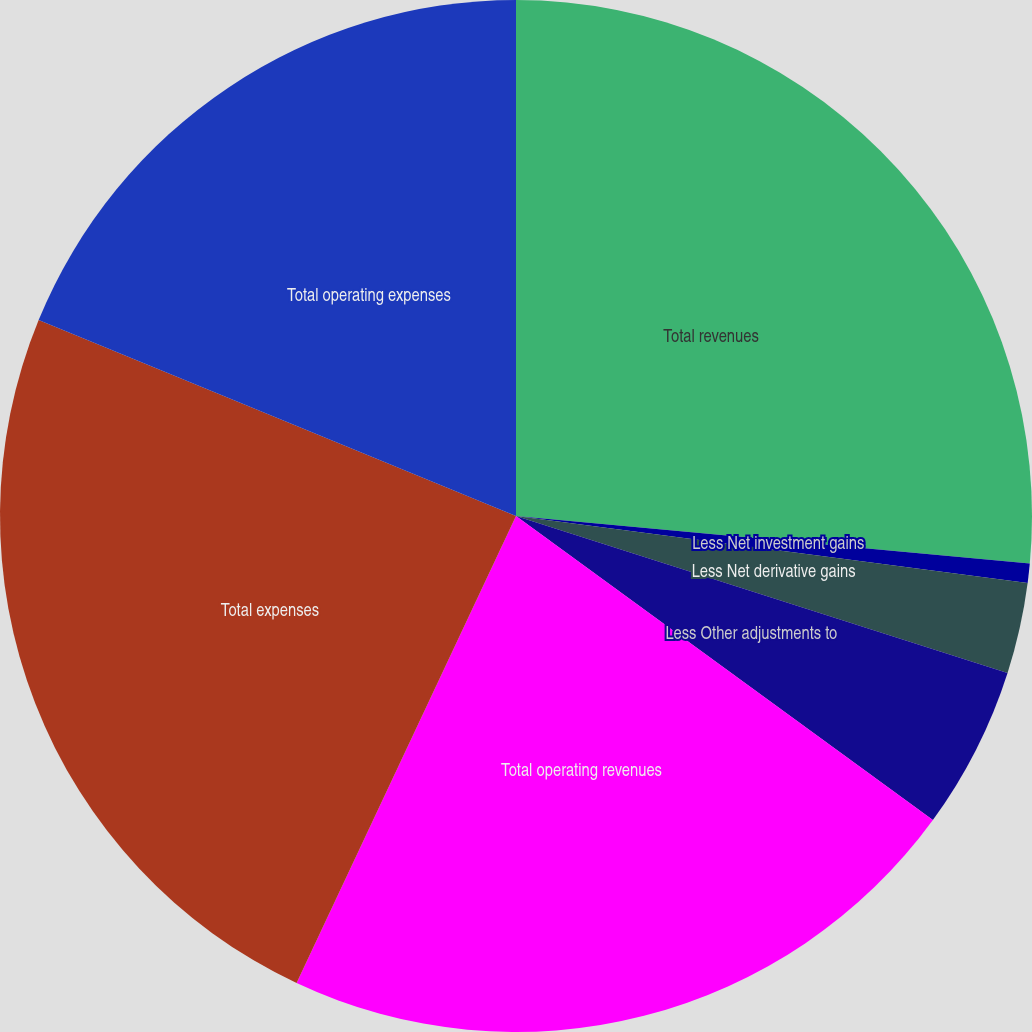<chart> <loc_0><loc_0><loc_500><loc_500><pie_chart><fcel>Total revenues<fcel>Less Net investment gains<fcel>Less Net derivative gains<fcel>Less Other adjustments to<fcel>Total operating revenues<fcel>Total expenses<fcel>Total operating expenses<nl><fcel>26.47%<fcel>0.6%<fcel>2.85%<fcel>5.11%<fcel>21.96%<fcel>24.21%<fcel>18.8%<nl></chart> 